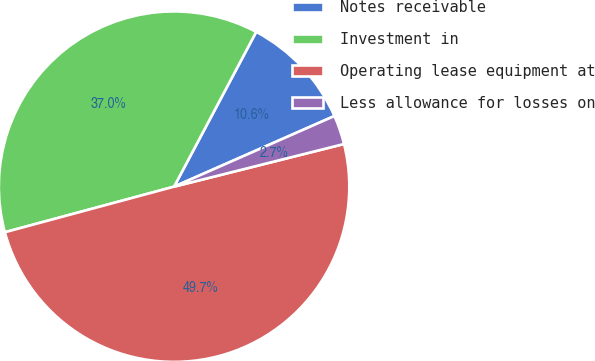<chart> <loc_0><loc_0><loc_500><loc_500><pie_chart><fcel>Notes receivable<fcel>Investment in<fcel>Operating lease equipment at<fcel>Less allowance for losses on<nl><fcel>10.63%<fcel>36.95%<fcel>49.72%<fcel>2.69%<nl></chart> 